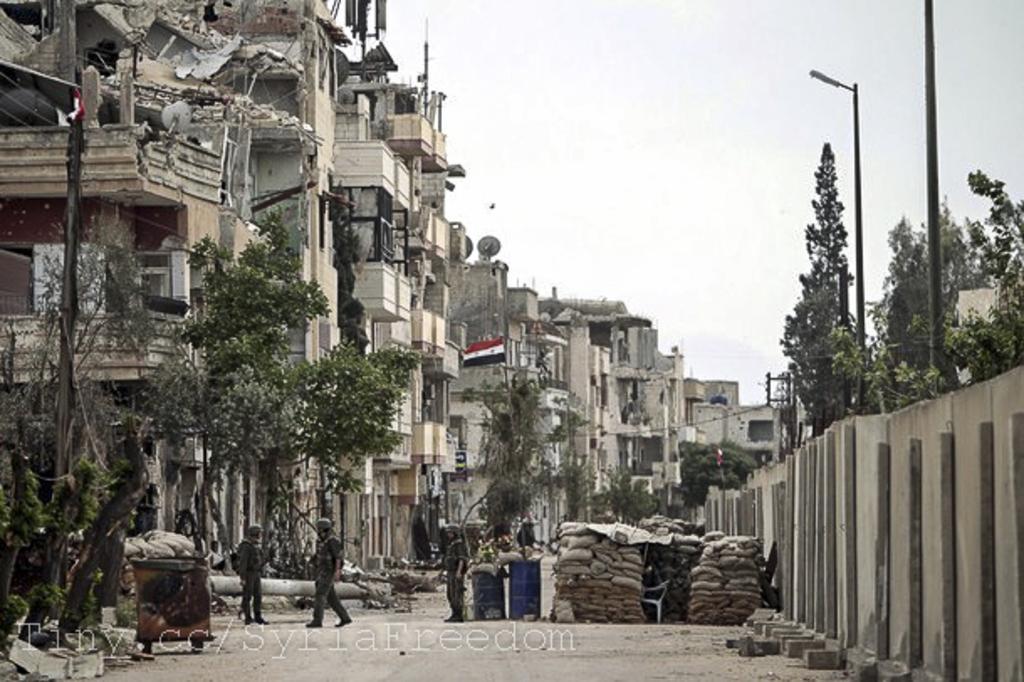In one or two sentences, can you explain what this image depicts? This image is clicked outside. There are trees in the middle. There are buildings in the middle. There are some persons at the bottom. There is sky at the top. 